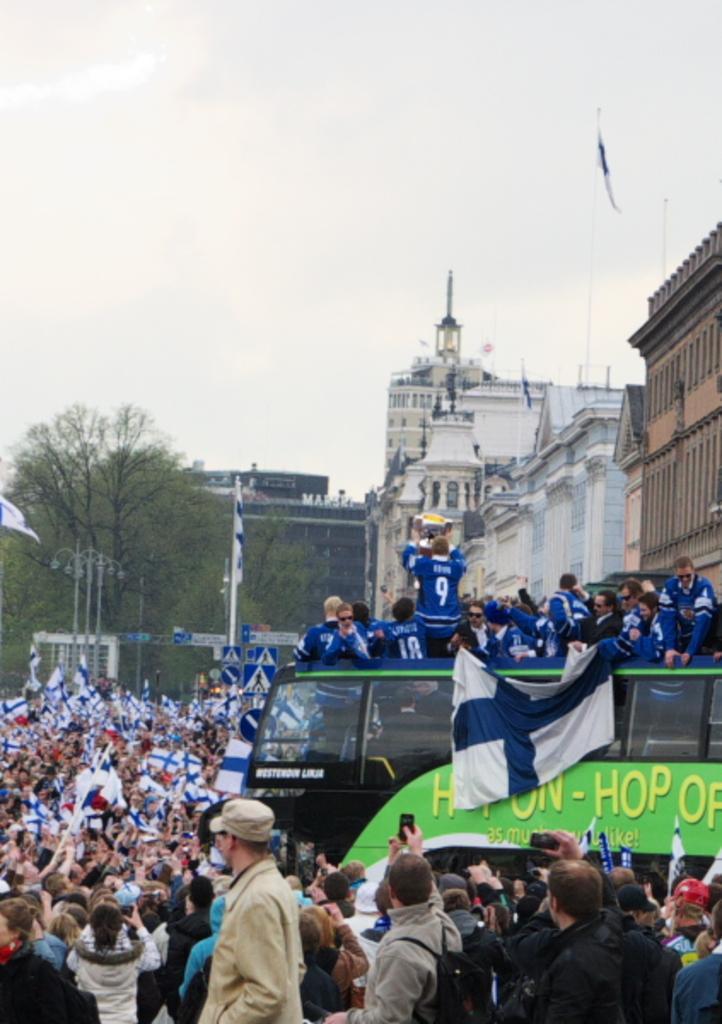How would you summarize this image in a sentence or two? In the image there is a green on the right side with people standing above it in blue jerseys, there are many people standing on the land holding flags taking pictures in phones, in the back there are buildings and trees and above its sky. 